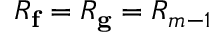Convert formula to latex. <formula><loc_0><loc_0><loc_500><loc_500>R _ { f } = R _ { g } = R _ { m - 1 }</formula> 